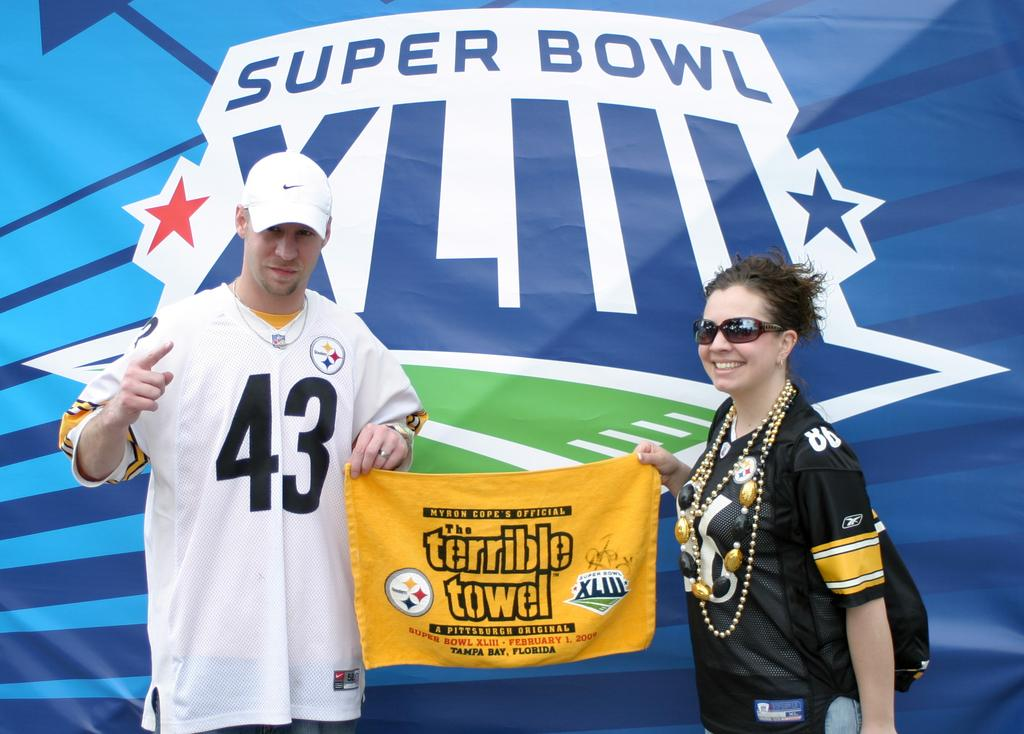<image>
Give a short and clear explanation of the subsequent image. A man and a woman in football jerseys pose with a "terrible towel" in front of a superbowl backdrop 